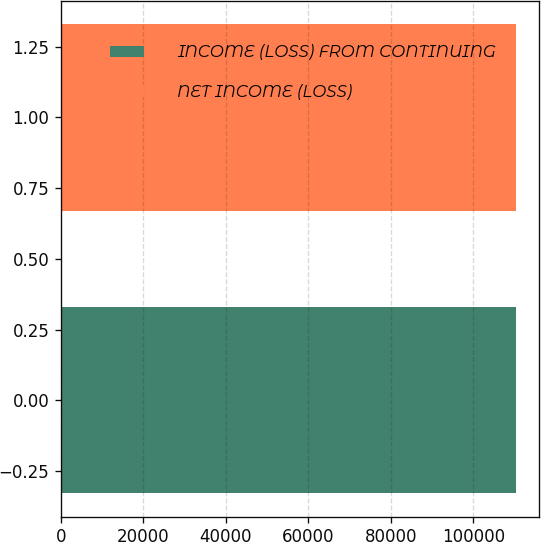<chart> <loc_0><loc_0><loc_500><loc_500><bar_chart><fcel>INCOME (LOSS) FROM CONTINUING<fcel>NET INCOME (LOSS)<nl><fcel>110398<fcel>110398<nl></chart> 